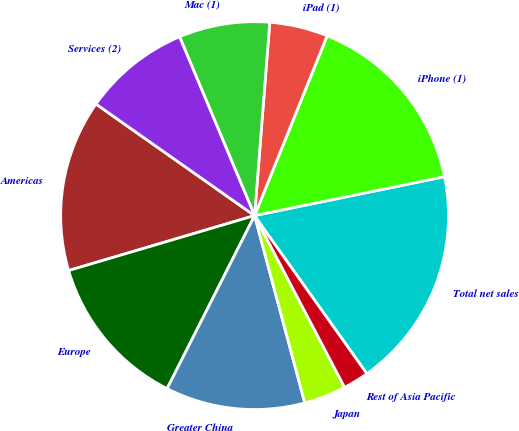<chart> <loc_0><loc_0><loc_500><loc_500><pie_chart><fcel>Americas<fcel>Europe<fcel>Greater China<fcel>Japan<fcel>Rest of Asia Pacific<fcel>Total net sales<fcel>iPhone (1)<fcel>iPad (1)<fcel>Mac (1)<fcel>Services (2)<nl><fcel>14.33%<fcel>12.98%<fcel>11.62%<fcel>3.51%<fcel>2.16%<fcel>18.38%<fcel>15.68%<fcel>4.86%<fcel>7.57%<fcel>8.92%<nl></chart> 